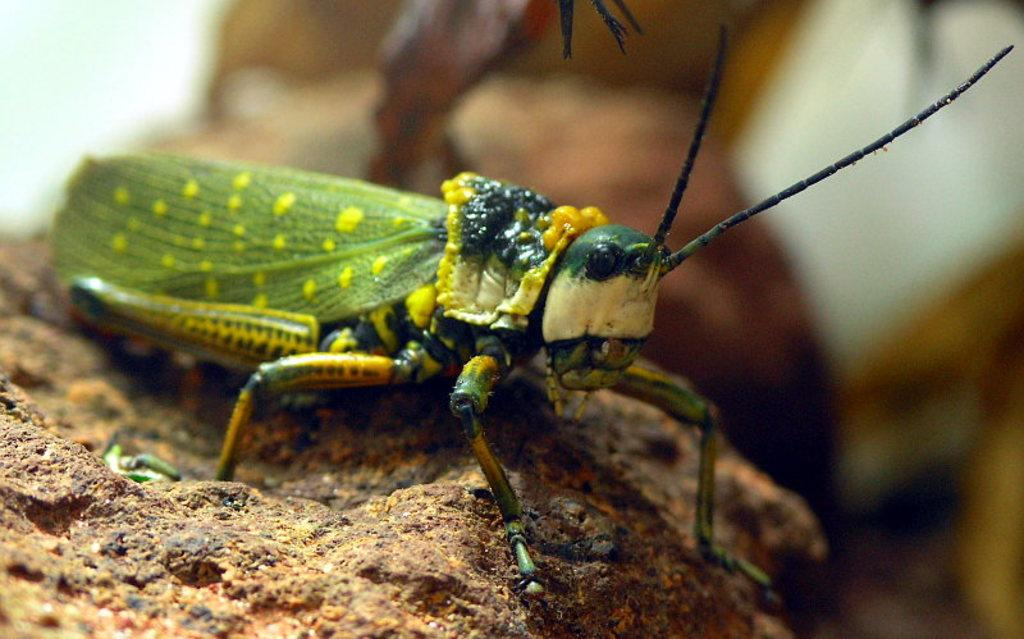What is the main subject of the image? There is an insect in the image. Where is the insect located? The insect is on a stone. Can you describe the background of the image? The background of the image is blurry. What type of jewel is the insect wearing on its leg in the image? There is no jewel present on the insect's leg in the image. How many rings can be seen on the insect's body in the image? There are no rings visible on the insect's body in the image. 